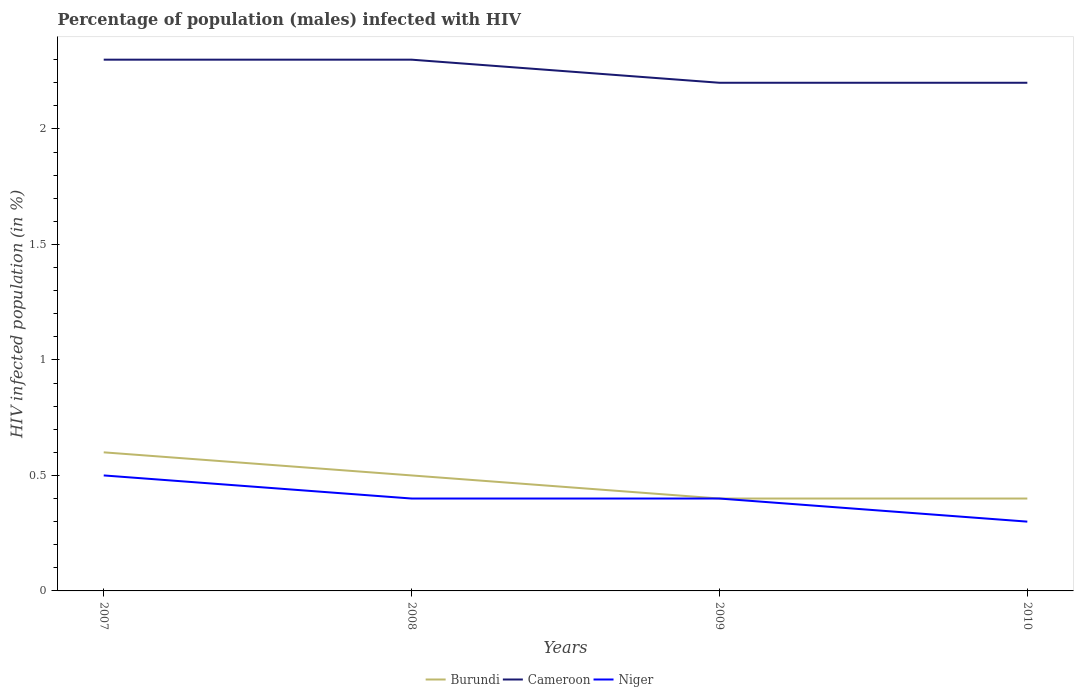How many different coloured lines are there?
Ensure brevity in your answer.  3. In which year was the percentage of HIV infected male population in Niger maximum?
Your answer should be very brief. 2010. What is the total percentage of HIV infected male population in Niger in the graph?
Ensure brevity in your answer.  0.1. What is the difference between the highest and the second highest percentage of HIV infected male population in Cameroon?
Make the answer very short. 0.1. How many lines are there?
Your response must be concise. 3. How many years are there in the graph?
Offer a terse response. 4. What is the difference between two consecutive major ticks on the Y-axis?
Provide a succinct answer. 0.5. Are the values on the major ticks of Y-axis written in scientific E-notation?
Ensure brevity in your answer.  No. Where does the legend appear in the graph?
Your answer should be compact. Bottom center. How are the legend labels stacked?
Your answer should be compact. Horizontal. What is the title of the graph?
Give a very brief answer. Percentage of population (males) infected with HIV. What is the label or title of the X-axis?
Offer a terse response. Years. What is the label or title of the Y-axis?
Give a very brief answer. HIV infected population (in %). What is the HIV infected population (in %) of Cameroon in 2007?
Provide a short and direct response. 2.3. What is the HIV infected population (in %) in Burundi in 2008?
Your answer should be very brief. 0.5. What is the HIV infected population (in %) in Cameroon in 2008?
Keep it short and to the point. 2.3. What is the HIV infected population (in %) in Niger in 2008?
Offer a very short reply. 0.4. What is the HIV infected population (in %) in Burundi in 2009?
Ensure brevity in your answer.  0.4. What is the HIV infected population (in %) in Cameroon in 2009?
Your answer should be compact. 2.2. What is the HIV infected population (in %) of Niger in 2009?
Give a very brief answer. 0.4. Across all years, what is the maximum HIV infected population (in %) in Burundi?
Keep it short and to the point. 0.6. Across all years, what is the minimum HIV infected population (in %) in Burundi?
Provide a succinct answer. 0.4. Across all years, what is the minimum HIV infected population (in %) of Cameroon?
Your answer should be very brief. 2.2. Across all years, what is the minimum HIV infected population (in %) of Niger?
Your response must be concise. 0.3. What is the total HIV infected population (in %) of Burundi in the graph?
Ensure brevity in your answer.  1.9. What is the total HIV infected population (in %) of Niger in the graph?
Provide a short and direct response. 1.6. What is the difference between the HIV infected population (in %) in Cameroon in 2007 and that in 2008?
Your answer should be compact. 0. What is the difference between the HIV infected population (in %) of Niger in 2007 and that in 2008?
Make the answer very short. 0.1. What is the difference between the HIV infected population (in %) in Burundi in 2007 and that in 2009?
Provide a succinct answer. 0.2. What is the difference between the HIV infected population (in %) of Cameroon in 2007 and that in 2009?
Offer a very short reply. 0.1. What is the difference between the HIV infected population (in %) of Niger in 2007 and that in 2009?
Your answer should be very brief. 0.1. What is the difference between the HIV infected population (in %) in Burundi in 2007 and that in 2010?
Your response must be concise. 0.2. What is the difference between the HIV infected population (in %) in Niger in 2007 and that in 2010?
Provide a short and direct response. 0.2. What is the difference between the HIV infected population (in %) of Burundi in 2008 and that in 2009?
Offer a terse response. 0.1. What is the difference between the HIV infected population (in %) in Burundi in 2008 and that in 2010?
Provide a succinct answer. 0.1. What is the difference between the HIV infected population (in %) of Cameroon in 2008 and that in 2010?
Provide a short and direct response. 0.1. What is the difference between the HIV infected population (in %) in Niger in 2008 and that in 2010?
Ensure brevity in your answer.  0.1. What is the difference between the HIV infected population (in %) of Niger in 2009 and that in 2010?
Your answer should be compact. 0.1. What is the difference between the HIV infected population (in %) in Burundi in 2007 and the HIV infected population (in %) in Cameroon in 2008?
Your response must be concise. -1.7. What is the difference between the HIV infected population (in %) of Cameroon in 2007 and the HIV infected population (in %) of Niger in 2008?
Make the answer very short. 1.9. What is the difference between the HIV infected population (in %) in Burundi in 2007 and the HIV infected population (in %) in Cameroon in 2009?
Offer a very short reply. -1.6. What is the difference between the HIV infected population (in %) in Burundi in 2007 and the HIV infected population (in %) in Niger in 2009?
Provide a short and direct response. 0.2. What is the difference between the HIV infected population (in %) in Cameroon in 2007 and the HIV infected population (in %) in Niger in 2009?
Give a very brief answer. 1.9. What is the difference between the HIV infected population (in %) of Burundi in 2007 and the HIV infected population (in %) of Cameroon in 2010?
Ensure brevity in your answer.  -1.6. What is the difference between the HIV infected population (in %) of Burundi in 2008 and the HIV infected population (in %) of Cameroon in 2009?
Offer a terse response. -1.7. What is the difference between the HIV infected population (in %) of Cameroon in 2008 and the HIV infected population (in %) of Niger in 2009?
Your response must be concise. 1.9. What is the difference between the HIV infected population (in %) of Burundi in 2008 and the HIV infected population (in %) of Cameroon in 2010?
Your answer should be compact. -1.7. What is the difference between the HIV infected population (in %) of Burundi in 2009 and the HIV infected population (in %) of Cameroon in 2010?
Provide a succinct answer. -1.8. What is the difference between the HIV infected population (in %) in Burundi in 2009 and the HIV infected population (in %) in Niger in 2010?
Offer a terse response. 0.1. What is the difference between the HIV infected population (in %) in Cameroon in 2009 and the HIV infected population (in %) in Niger in 2010?
Provide a short and direct response. 1.9. What is the average HIV infected population (in %) in Burundi per year?
Your answer should be compact. 0.47. What is the average HIV infected population (in %) in Cameroon per year?
Offer a very short reply. 2.25. What is the average HIV infected population (in %) in Niger per year?
Your response must be concise. 0.4. In the year 2007, what is the difference between the HIV infected population (in %) in Burundi and HIV infected population (in %) in Cameroon?
Keep it short and to the point. -1.7. In the year 2007, what is the difference between the HIV infected population (in %) of Cameroon and HIV infected population (in %) of Niger?
Provide a short and direct response. 1.8. In the year 2008, what is the difference between the HIV infected population (in %) of Burundi and HIV infected population (in %) of Cameroon?
Your answer should be compact. -1.8. In the year 2008, what is the difference between the HIV infected population (in %) in Burundi and HIV infected population (in %) in Niger?
Offer a very short reply. 0.1. In the year 2009, what is the difference between the HIV infected population (in %) in Burundi and HIV infected population (in %) in Cameroon?
Offer a terse response. -1.8. In the year 2009, what is the difference between the HIV infected population (in %) of Burundi and HIV infected population (in %) of Niger?
Ensure brevity in your answer.  0. In the year 2009, what is the difference between the HIV infected population (in %) in Cameroon and HIV infected population (in %) in Niger?
Provide a succinct answer. 1.8. In the year 2010, what is the difference between the HIV infected population (in %) in Burundi and HIV infected population (in %) in Niger?
Provide a succinct answer. 0.1. What is the ratio of the HIV infected population (in %) in Burundi in 2007 to that in 2008?
Your answer should be very brief. 1.2. What is the ratio of the HIV infected population (in %) in Cameroon in 2007 to that in 2008?
Give a very brief answer. 1. What is the ratio of the HIV infected population (in %) of Niger in 2007 to that in 2008?
Keep it short and to the point. 1.25. What is the ratio of the HIV infected population (in %) of Cameroon in 2007 to that in 2009?
Provide a short and direct response. 1.05. What is the ratio of the HIV infected population (in %) of Niger in 2007 to that in 2009?
Your answer should be compact. 1.25. What is the ratio of the HIV infected population (in %) of Burundi in 2007 to that in 2010?
Ensure brevity in your answer.  1.5. What is the ratio of the HIV infected population (in %) of Cameroon in 2007 to that in 2010?
Make the answer very short. 1.05. What is the ratio of the HIV infected population (in %) in Niger in 2007 to that in 2010?
Your answer should be very brief. 1.67. What is the ratio of the HIV infected population (in %) in Cameroon in 2008 to that in 2009?
Make the answer very short. 1.05. What is the ratio of the HIV infected population (in %) of Niger in 2008 to that in 2009?
Your answer should be compact. 1. What is the ratio of the HIV infected population (in %) of Burundi in 2008 to that in 2010?
Ensure brevity in your answer.  1.25. What is the ratio of the HIV infected population (in %) of Cameroon in 2008 to that in 2010?
Offer a very short reply. 1.05. What is the ratio of the HIV infected population (in %) in Niger in 2008 to that in 2010?
Offer a terse response. 1.33. What is the difference between the highest and the second highest HIV infected population (in %) in Burundi?
Your response must be concise. 0.1. What is the difference between the highest and the second highest HIV infected population (in %) in Niger?
Offer a very short reply. 0.1. What is the difference between the highest and the lowest HIV infected population (in %) in Niger?
Offer a very short reply. 0.2. 